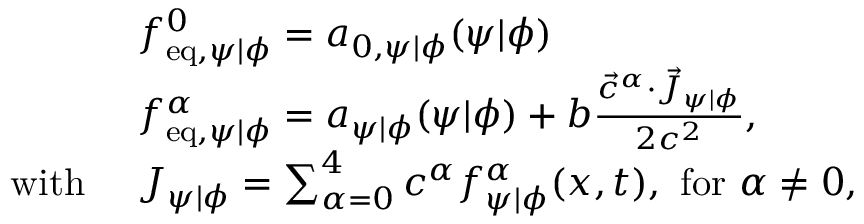Convert formula to latex. <formula><loc_0><loc_0><loc_500><loc_500>\begin{array} { r l } & { f _ { e q , \psi | \phi } ^ { 0 } = a _ { 0 , \psi | \phi } ( \psi | \phi ) } \\ & { f _ { e q , \psi | \phi } ^ { \alpha } = a _ { \psi | \phi } ( \psi | \phi ) + b \frac { \vec { c } ^ { \alpha } \cdot \vec { J } _ { \psi | \phi } } { 2 c ^ { 2 } } , } \\ { w i t h \ } & { J _ { \psi | \phi } = \sum _ { \alpha = 0 } ^ { 4 } c ^ { \alpha } f _ { \psi | \phi } ^ { \alpha } ( x , t ) , \ f o r \alpha \neq 0 , } \end{array}</formula> 